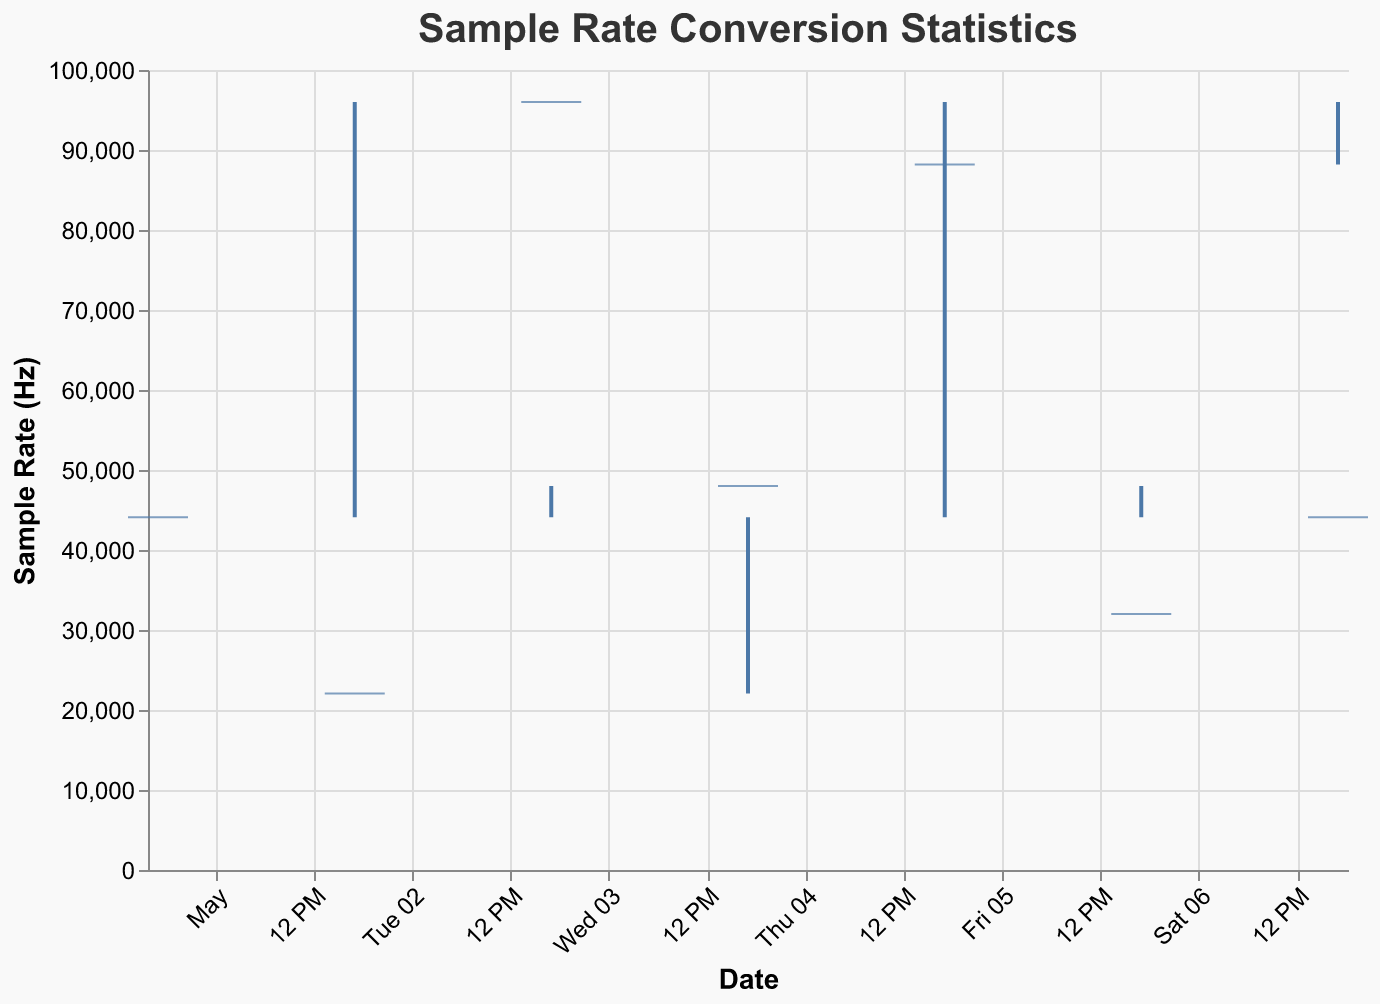What is the title of the chart? The title of the chart is usually displayed at the top of the figure. In this case, it states "Sample Rate Conversion Statistics."
Answer: Sample Rate Conversion Statistics How many data points are displayed in the chart? Each bar corresponds to a different date entry, and we can count them to see there are seven bars, each representing a different date.
Answer: 7 What is the input sample rate on 2023-05-03? The figure uses red ticks to indicate the input sample rate, and for 2023-05-03, this tick is positioned at 96000 Hz.
Answer: 96000 Hz Which date shows the highest output rate high value? By observing the upper end of the vertical lines for the output rates, the highest point appears on 2023-05-02 and 2023-05-05, both at 96000 Hz.
Answer: 2023-05-02 and 2023-05-05 What is the conversion time open on 2023-05-06? For each date, the start of the blue bar represents the conversion time open. On 2023-05-06, this bar starts at 0.2 seconds.
Answer: 0.2 On which date is the output rate low the smallest? The lowest points of the vertical lines for the output rates show the smallest value. On 2023-05-04, this point is at 22050 Hz.
Answer: 2023-05-04 What's the average conversion time close over all the dates? Summing up the values of conversion time close for each date (0.7 + 0.9 + 1.2 + 0.6 + 1.1 + 0.5 + 0.8) gives 5.8. Since there are 7 data points, the average is 5.8 / 7 ≈ 0.83.
Answer: 0.83 Which date has the smallest difference between conversion time open and conversion time close? Calculating the difference for each date: 0.7-0.5=0.2, 0.9-0.3=0.6, 1.2-0.8=0.4, 0.6-0.4=0.2, 1.1-0.7=0.4, 0.5-0.2=0.3, 0.8-0.6=0.2. Dates 2023-05-01, 2023-05-04, and 2023-05-07 have the smallest difference of 0.2 seconds.
Answer: 2023-05-01, 2023-05-04, and 2023-05-07 How do the input sample rates on 2023-05-01 and 2023-05-07 compare? Both dates have the same input sample rate as indicated by the same red tick position at 44100 Hz for each date.
Answer: They are the same What is the range of the output rate on 2023-05-02? The output rate on 2023-05-02 ranges from the low value of 44100 Hz to the high value of 96000 Hz, giving a range of 96000 - 44100 = 51900 Hz.
Answer: 51900 Hz 